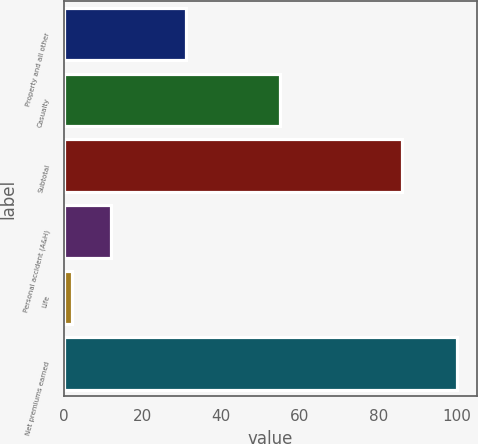<chart> <loc_0><loc_0><loc_500><loc_500><bar_chart><fcel>Property and all other<fcel>Casualty<fcel>Subtotal<fcel>Personal accident (A&H)<fcel>Life<fcel>Net premiums earned<nl><fcel>31<fcel>55<fcel>86<fcel>12<fcel>2<fcel>100<nl></chart> 